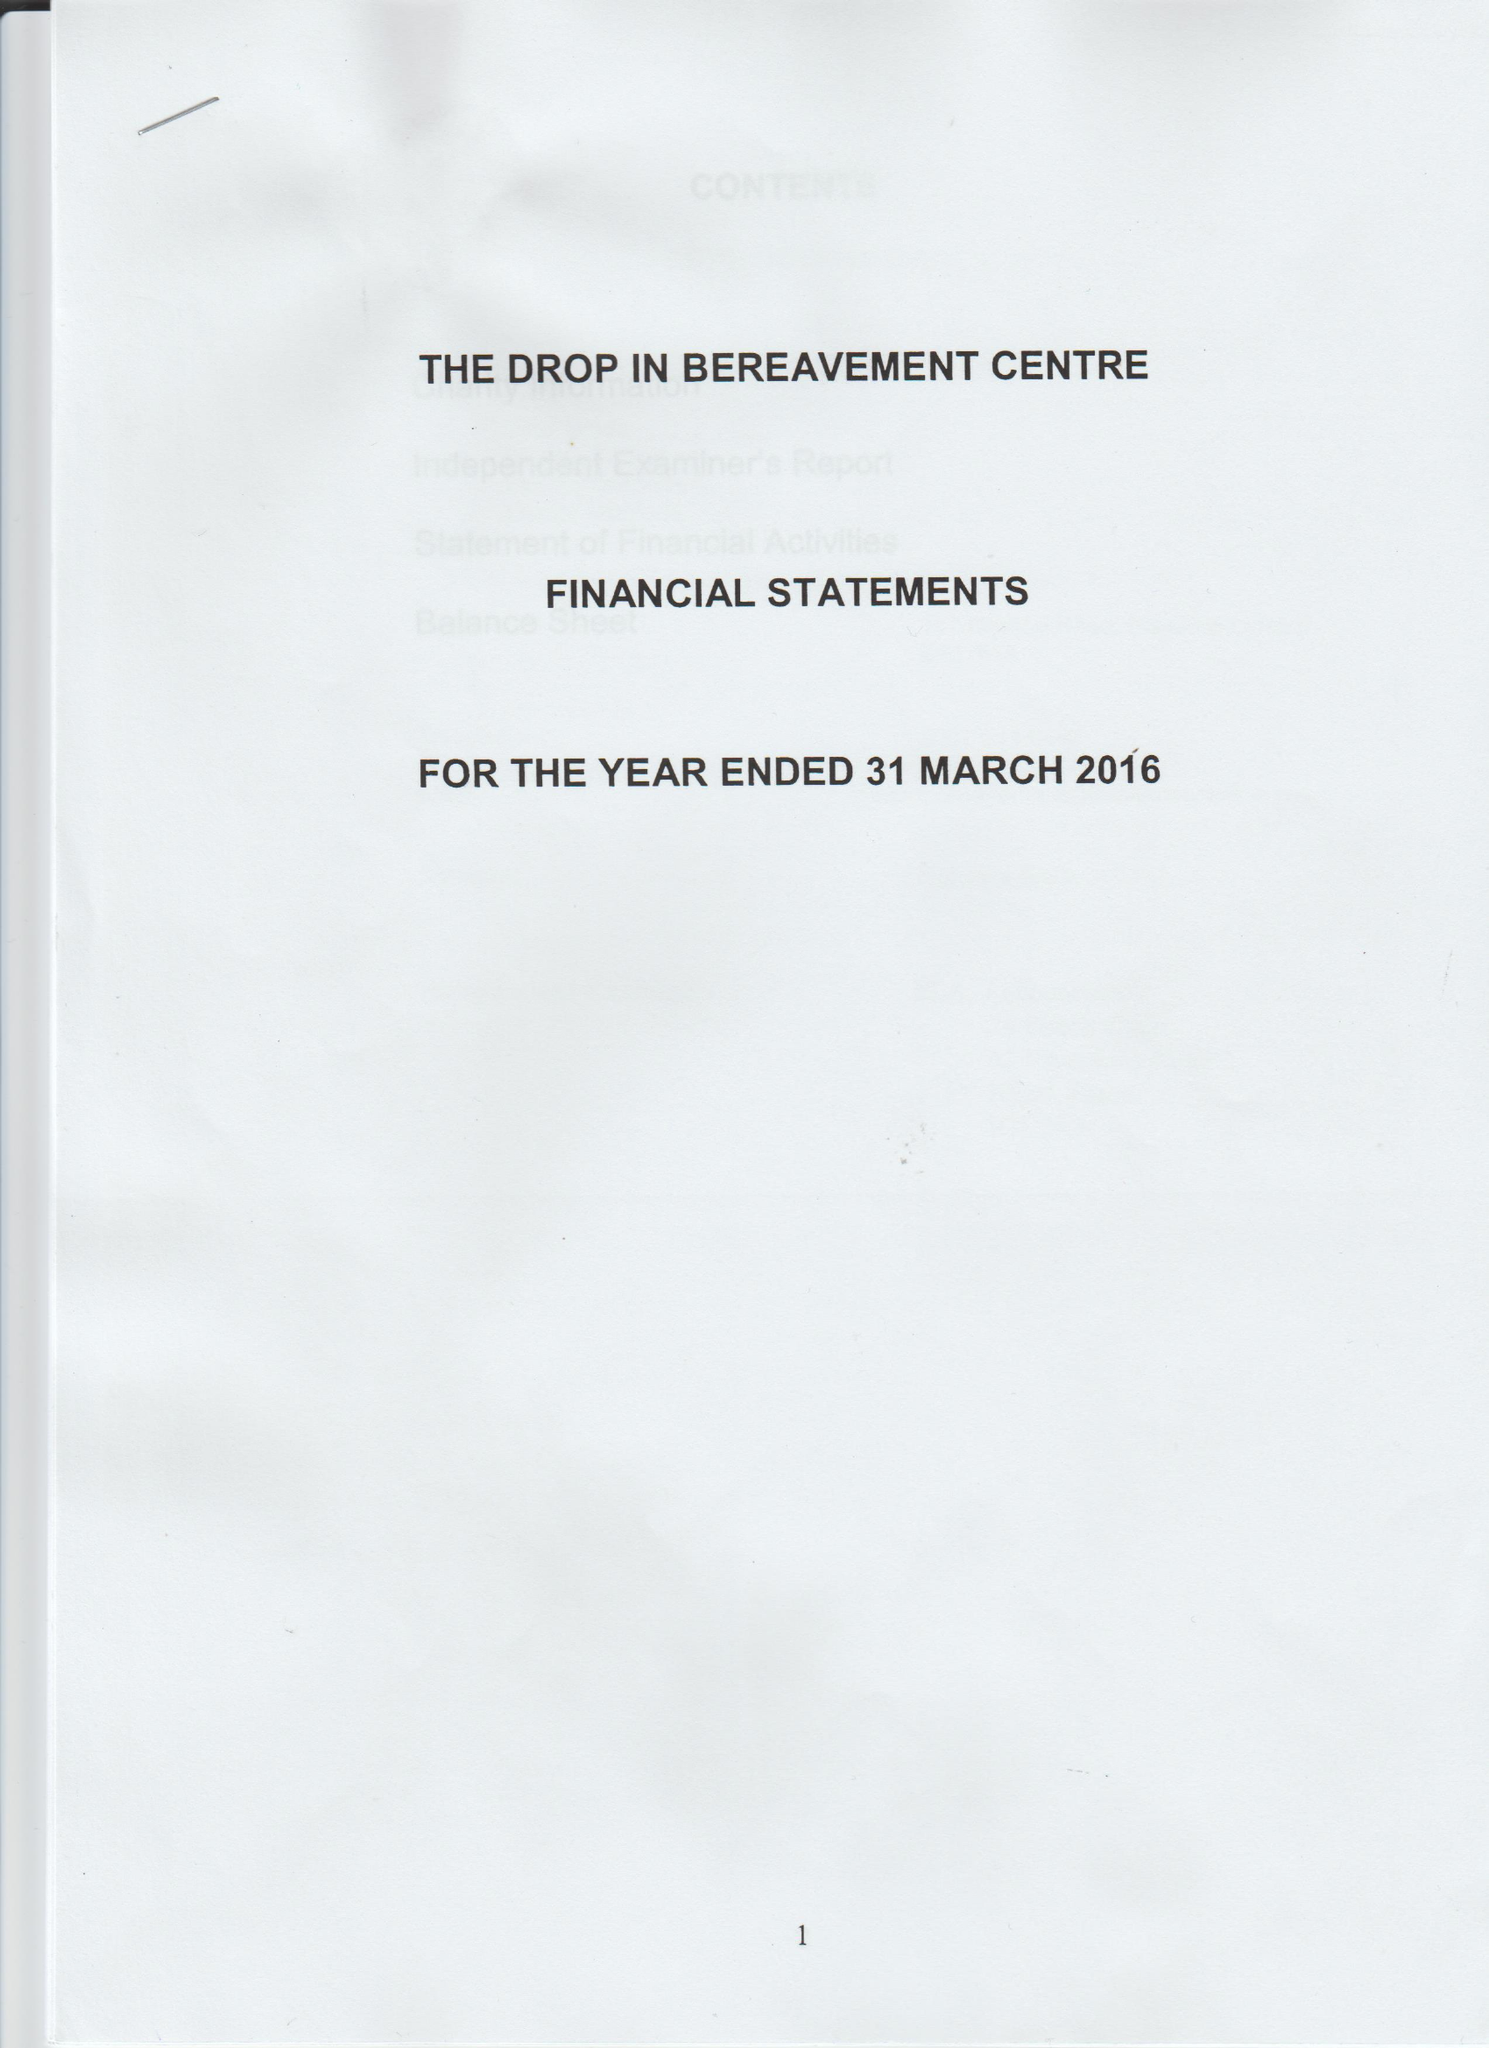What is the value for the income_annually_in_british_pounds?
Answer the question using a single word or phrase. 45825.00 